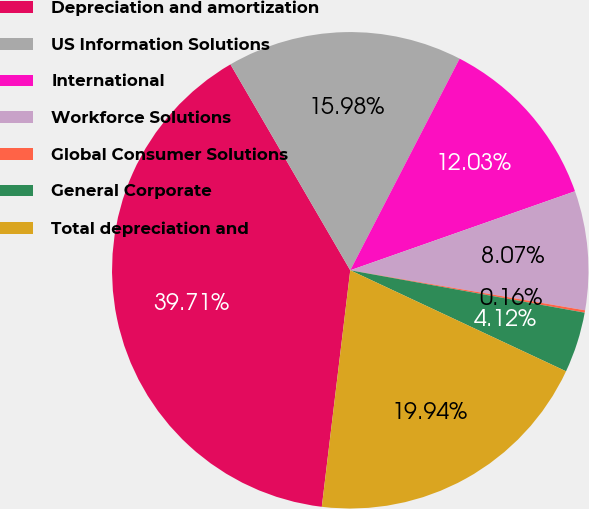<chart> <loc_0><loc_0><loc_500><loc_500><pie_chart><fcel>Depreciation and amortization<fcel>US Information Solutions<fcel>International<fcel>Workforce Solutions<fcel>Global Consumer Solutions<fcel>General Corporate<fcel>Total depreciation and<nl><fcel>39.71%<fcel>15.98%<fcel>12.03%<fcel>8.07%<fcel>0.16%<fcel>4.12%<fcel>19.94%<nl></chart> 